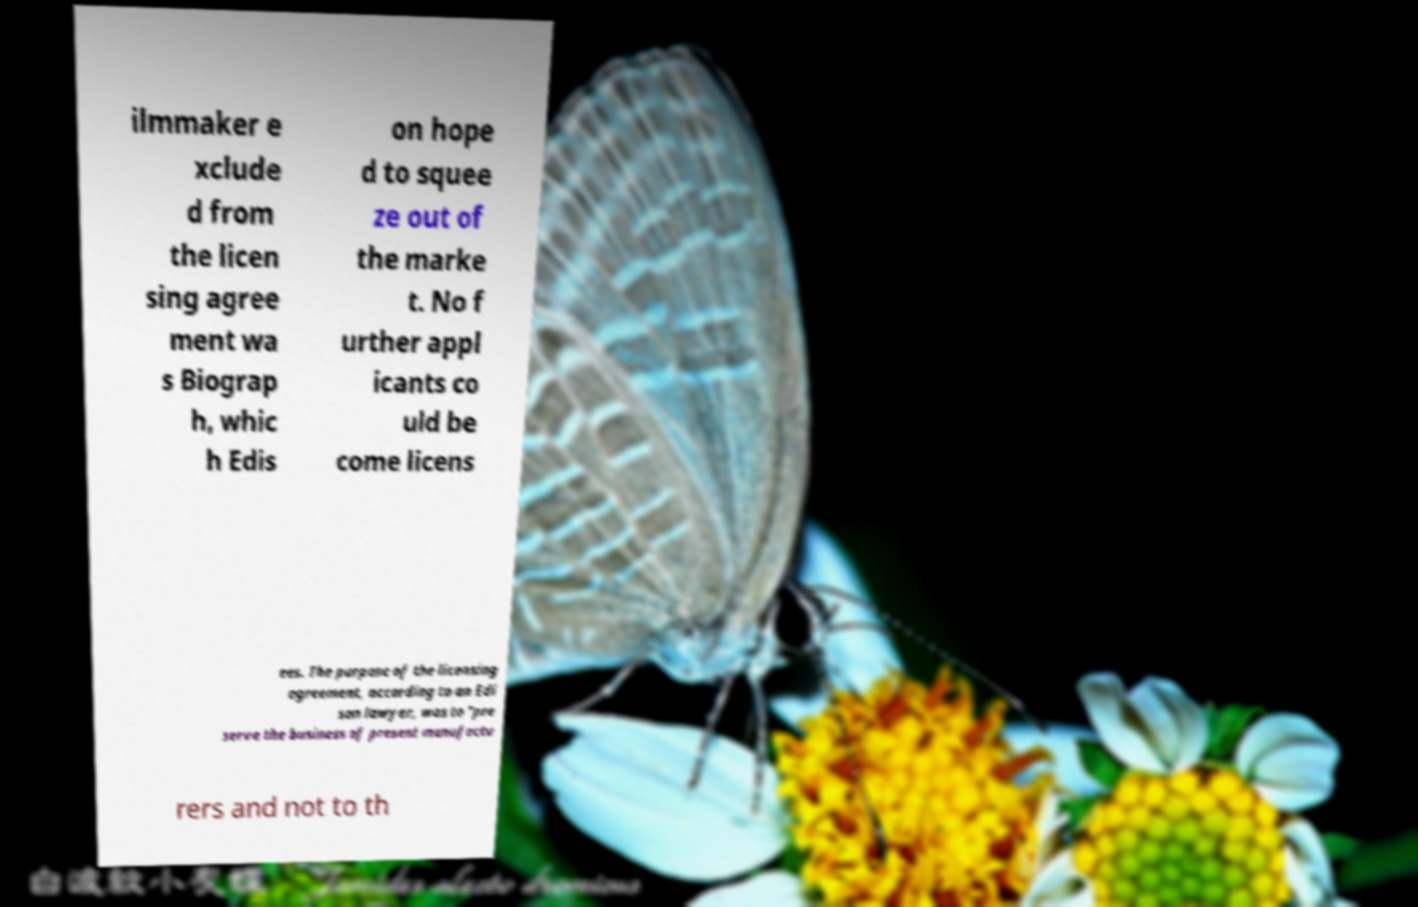Could you extract and type out the text from this image? ilmmaker e xclude d from the licen sing agree ment wa s Biograp h, whic h Edis on hope d to squee ze out of the marke t. No f urther appl icants co uld be come licens ees. The purpose of the licensing agreement, according to an Edi son lawyer, was to "pre serve the business of present manufactu rers and not to th 